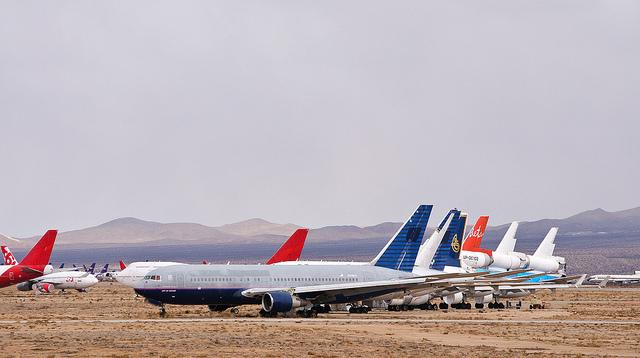What is the blue back piece of the plane called? tail 